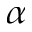Convert formula to latex. <formula><loc_0><loc_0><loc_500><loc_500>\alpha</formula> 